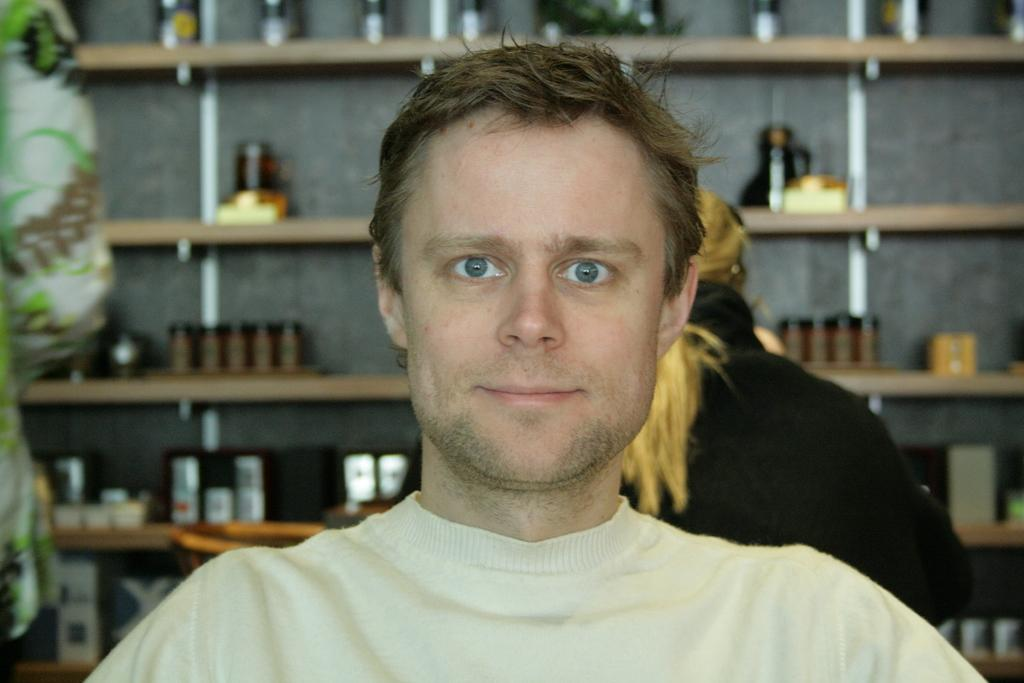Who is present in the image? There is a man in the image. What is the man wearing? The man is wearing a t-shirt. What is the man doing in the image? The man is looking at a picture. Can you describe the background of the image? There are people and a rack visible. A: Yes, there are people in the background of the image, as well as a rack with boxes and bottles arranged on it. What type of chance does the man have of winning the lottery in the image? There is no information about the lottery or any chance of winning in the image. How does the celery contribute to the overall composition of the image? There is no celery present in the image. 